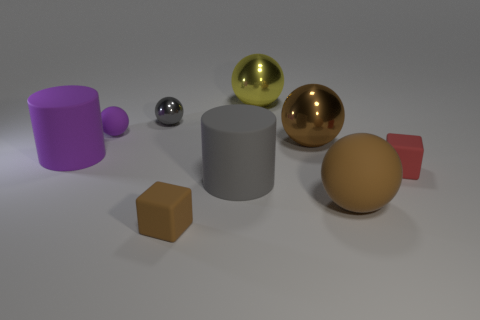Describe the differences between the objects' surfaces. The objects exhibit a variety of surfaces: the spheres have a shiny, reflective finish; the cube and cylinder are matte; and the rounded cube has a slightly textured appearance. 